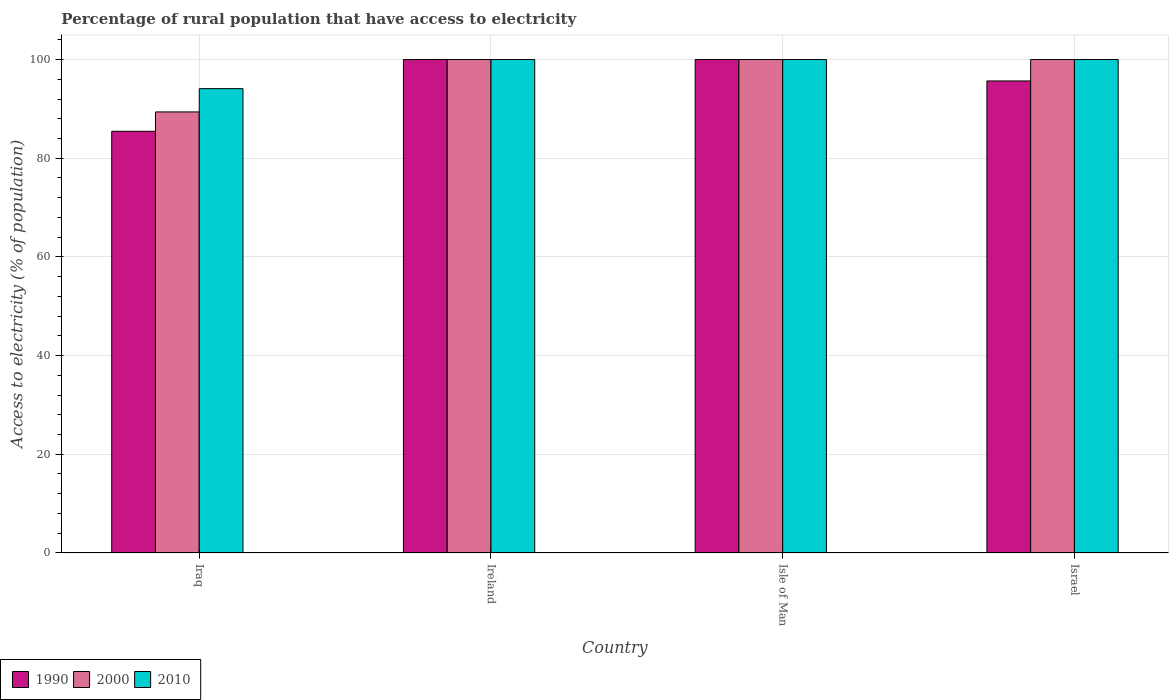How many different coloured bars are there?
Keep it short and to the point. 3. How many groups of bars are there?
Your response must be concise. 4. Are the number of bars per tick equal to the number of legend labels?
Your response must be concise. Yes. Are the number of bars on each tick of the X-axis equal?
Provide a short and direct response. Yes. How many bars are there on the 4th tick from the right?
Your answer should be very brief. 3. What is the label of the 3rd group of bars from the left?
Give a very brief answer. Isle of Man. What is the percentage of rural population that have access to electricity in 1990 in Israel?
Offer a very short reply. 95.66. Across all countries, what is the minimum percentage of rural population that have access to electricity in 1990?
Your answer should be compact. 85.46. In which country was the percentage of rural population that have access to electricity in 2010 maximum?
Provide a short and direct response. Ireland. In which country was the percentage of rural population that have access to electricity in 2010 minimum?
Keep it short and to the point. Iraq. What is the total percentage of rural population that have access to electricity in 1990 in the graph?
Your answer should be very brief. 381.12. What is the difference between the percentage of rural population that have access to electricity in 1990 in Iraq and that in Israel?
Ensure brevity in your answer.  -10.2. What is the difference between the percentage of rural population that have access to electricity in 2000 in Israel and the percentage of rural population that have access to electricity in 1990 in Iraq?
Your answer should be compact. 14.54. What is the average percentage of rural population that have access to electricity in 2000 per country?
Your answer should be compact. 97.35. What is the difference between the percentage of rural population that have access to electricity of/in 2000 and percentage of rural population that have access to electricity of/in 2010 in Iraq?
Offer a terse response. -4.72. Is the percentage of rural population that have access to electricity in 2010 in Ireland less than that in Israel?
Your answer should be very brief. No. Is the difference between the percentage of rural population that have access to electricity in 2000 in Iraq and Israel greater than the difference between the percentage of rural population that have access to electricity in 2010 in Iraq and Israel?
Make the answer very short. No. What is the difference between the highest and the second highest percentage of rural population that have access to electricity in 1990?
Give a very brief answer. 4.34. What is the difference between the highest and the lowest percentage of rural population that have access to electricity in 2000?
Give a very brief answer. 10.62. In how many countries, is the percentage of rural population that have access to electricity in 1990 greater than the average percentage of rural population that have access to electricity in 1990 taken over all countries?
Make the answer very short. 3. Is the sum of the percentage of rural population that have access to electricity in 1990 in Iraq and Israel greater than the maximum percentage of rural population that have access to electricity in 2010 across all countries?
Provide a short and direct response. Yes. Is it the case that in every country, the sum of the percentage of rural population that have access to electricity in 2010 and percentage of rural population that have access to electricity in 1990 is greater than the percentage of rural population that have access to electricity in 2000?
Your answer should be very brief. Yes. What is the difference between two consecutive major ticks on the Y-axis?
Your response must be concise. 20. Are the values on the major ticks of Y-axis written in scientific E-notation?
Your response must be concise. No. Where does the legend appear in the graph?
Your response must be concise. Bottom left. How many legend labels are there?
Your answer should be very brief. 3. What is the title of the graph?
Provide a short and direct response. Percentage of rural population that have access to electricity. What is the label or title of the X-axis?
Keep it short and to the point. Country. What is the label or title of the Y-axis?
Provide a short and direct response. Access to electricity (% of population). What is the Access to electricity (% of population) of 1990 in Iraq?
Your answer should be very brief. 85.46. What is the Access to electricity (% of population) of 2000 in Iraq?
Offer a very short reply. 89.38. What is the Access to electricity (% of population) of 2010 in Iraq?
Ensure brevity in your answer.  94.1. What is the Access to electricity (% of population) of 1990 in Ireland?
Your answer should be very brief. 100. What is the Access to electricity (% of population) in 2010 in Ireland?
Provide a succinct answer. 100. What is the Access to electricity (% of population) of 2000 in Isle of Man?
Your answer should be compact. 100. What is the Access to electricity (% of population) of 1990 in Israel?
Offer a very short reply. 95.66. What is the Access to electricity (% of population) in 2000 in Israel?
Keep it short and to the point. 100. What is the Access to electricity (% of population) of 2010 in Israel?
Ensure brevity in your answer.  100. Across all countries, what is the maximum Access to electricity (% of population) of 1990?
Your answer should be compact. 100. Across all countries, what is the minimum Access to electricity (% of population) of 1990?
Your answer should be very brief. 85.46. Across all countries, what is the minimum Access to electricity (% of population) in 2000?
Keep it short and to the point. 89.38. Across all countries, what is the minimum Access to electricity (% of population) in 2010?
Make the answer very short. 94.1. What is the total Access to electricity (% of population) in 1990 in the graph?
Your response must be concise. 381.12. What is the total Access to electricity (% of population) of 2000 in the graph?
Your response must be concise. 389.38. What is the total Access to electricity (% of population) of 2010 in the graph?
Your response must be concise. 394.1. What is the difference between the Access to electricity (% of population) of 1990 in Iraq and that in Ireland?
Provide a succinct answer. -14.54. What is the difference between the Access to electricity (% of population) in 2000 in Iraq and that in Ireland?
Your answer should be compact. -10.62. What is the difference between the Access to electricity (% of population) of 1990 in Iraq and that in Isle of Man?
Offer a terse response. -14.54. What is the difference between the Access to electricity (% of population) in 2000 in Iraq and that in Isle of Man?
Keep it short and to the point. -10.62. What is the difference between the Access to electricity (% of population) of 2010 in Iraq and that in Isle of Man?
Keep it short and to the point. -5.9. What is the difference between the Access to electricity (% of population) of 1990 in Iraq and that in Israel?
Your response must be concise. -10.2. What is the difference between the Access to electricity (% of population) in 2000 in Iraq and that in Israel?
Offer a terse response. -10.62. What is the difference between the Access to electricity (% of population) in 2010 in Iraq and that in Israel?
Provide a short and direct response. -5.9. What is the difference between the Access to electricity (% of population) in 2010 in Ireland and that in Isle of Man?
Give a very brief answer. 0. What is the difference between the Access to electricity (% of population) of 1990 in Ireland and that in Israel?
Your answer should be very brief. 4.34. What is the difference between the Access to electricity (% of population) in 2000 in Ireland and that in Israel?
Make the answer very short. 0. What is the difference between the Access to electricity (% of population) in 2010 in Ireland and that in Israel?
Provide a succinct answer. 0. What is the difference between the Access to electricity (% of population) of 1990 in Isle of Man and that in Israel?
Make the answer very short. 4.34. What is the difference between the Access to electricity (% of population) in 2000 in Isle of Man and that in Israel?
Ensure brevity in your answer.  0. What is the difference between the Access to electricity (% of population) in 1990 in Iraq and the Access to electricity (% of population) in 2000 in Ireland?
Keep it short and to the point. -14.54. What is the difference between the Access to electricity (% of population) in 1990 in Iraq and the Access to electricity (% of population) in 2010 in Ireland?
Ensure brevity in your answer.  -14.54. What is the difference between the Access to electricity (% of population) of 2000 in Iraq and the Access to electricity (% of population) of 2010 in Ireland?
Your response must be concise. -10.62. What is the difference between the Access to electricity (% of population) of 1990 in Iraq and the Access to electricity (% of population) of 2000 in Isle of Man?
Make the answer very short. -14.54. What is the difference between the Access to electricity (% of population) in 1990 in Iraq and the Access to electricity (% of population) in 2010 in Isle of Man?
Provide a short and direct response. -14.54. What is the difference between the Access to electricity (% of population) in 2000 in Iraq and the Access to electricity (% of population) in 2010 in Isle of Man?
Your answer should be very brief. -10.62. What is the difference between the Access to electricity (% of population) in 1990 in Iraq and the Access to electricity (% of population) in 2000 in Israel?
Ensure brevity in your answer.  -14.54. What is the difference between the Access to electricity (% of population) in 1990 in Iraq and the Access to electricity (% of population) in 2010 in Israel?
Keep it short and to the point. -14.54. What is the difference between the Access to electricity (% of population) in 2000 in Iraq and the Access to electricity (% of population) in 2010 in Israel?
Ensure brevity in your answer.  -10.62. What is the difference between the Access to electricity (% of population) in 1990 in Ireland and the Access to electricity (% of population) in 2000 in Isle of Man?
Offer a terse response. 0. What is the difference between the Access to electricity (% of population) of 1990 in Ireland and the Access to electricity (% of population) of 2010 in Isle of Man?
Your answer should be compact. 0. What is the difference between the Access to electricity (% of population) of 2000 in Ireland and the Access to electricity (% of population) of 2010 in Isle of Man?
Provide a short and direct response. 0. What is the difference between the Access to electricity (% of population) of 1990 in Ireland and the Access to electricity (% of population) of 2010 in Israel?
Provide a short and direct response. 0. What is the difference between the Access to electricity (% of population) of 1990 in Isle of Man and the Access to electricity (% of population) of 2010 in Israel?
Provide a succinct answer. 0. What is the average Access to electricity (% of population) of 1990 per country?
Make the answer very short. 95.28. What is the average Access to electricity (% of population) in 2000 per country?
Ensure brevity in your answer.  97.35. What is the average Access to electricity (% of population) of 2010 per country?
Provide a succinct answer. 98.53. What is the difference between the Access to electricity (% of population) in 1990 and Access to electricity (% of population) in 2000 in Iraq?
Offer a terse response. -3.92. What is the difference between the Access to electricity (% of population) of 1990 and Access to electricity (% of population) of 2010 in Iraq?
Give a very brief answer. -8.64. What is the difference between the Access to electricity (% of population) of 2000 and Access to electricity (% of population) of 2010 in Iraq?
Your answer should be very brief. -4.72. What is the difference between the Access to electricity (% of population) of 1990 and Access to electricity (% of population) of 2000 in Ireland?
Offer a terse response. 0. What is the difference between the Access to electricity (% of population) of 1990 and Access to electricity (% of population) of 2010 in Ireland?
Offer a very short reply. 0. What is the difference between the Access to electricity (% of population) in 1990 and Access to electricity (% of population) in 2000 in Israel?
Your answer should be very brief. -4.34. What is the difference between the Access to electricity (% of population) of 1990 and Access to electricity (% of population) of 2010 in Israel?
Your response must be concise. -4.34. What is the ratio of the Access to electricity (% of population) of 1990 in Iraq to that in Ireland?
Keep it short and to the point. 0.85. What is the ratio of the Access to electricity (% of population) in 2000 in Iraq to that in Ireland?
Your answer should be very brief. 0.89. What is the ratio of the Access to electricity (% of population) of 2010 in Iraq to that in Ireland?
Give a very brief answer. 0.94. What is the ratio of the Access to electricity (% of population) of 1990 in Iraq to that in Isle of Man?
Give a very brief answer. 0.85. What is the ratio of the Access to electricity (% of population) in 2000 in Iraq to that in Isle of Man?
Offer a very short reply. 0.89. What is the ratio of the Access to electricity (% of population) in 2010 in Iraq to that in Isle of Man?
Make the answer very short. 0.94. What is the ratio of the Access to electricity (% of population) in 1990 in Iraq to that in Israel?
Give a very brief answer. 0.89. What is the ratio of the Access to electricity (% of population) in 2000 in Iraq to that in Israel?
Offer a terse response. 0.89. What is the ratio of the Access to electricity (% of population) of 2010 in Iraq to that in Israel?
Your response must be concise. 0.94. What is the ratio of the Access to electricity (% of population) of 1990 in Ireland to that in Israel?
Ensure brevity in your answer.  1.05. What is the ratio of the Access to electricity (% of population) of 2010 in Ireland to that in Israel?
Your answer should be very brief. 1. What is the ratio of the Access to electricity (% of population) of 1990 in Isle of Man to that in Israel?
Your response must be concise. 1.05. What is the difference between the highest and the second highest Access to electricity (% of population) of 2010?
Give a very brief answer. 0. What is the difference between the highest and the lowest Access to electricity (% of population) of 1990?
Your response must be concise. 14.54. What is the difference between the highest and the lowest Access to electricity (% of population) in 2000?
Give a very brief answer. 10.62. What is the difference between the highest and the lowest Access to electricity (% of population) in 2010?
Ensure brevity in your answer.  5.9. 